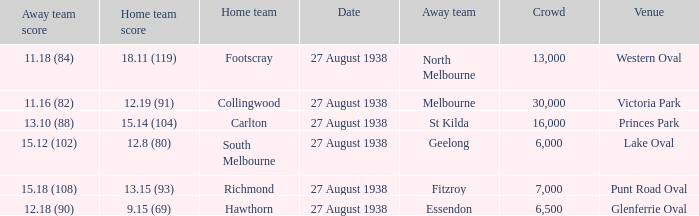Which Team plays at Western Oval? Footscray. 